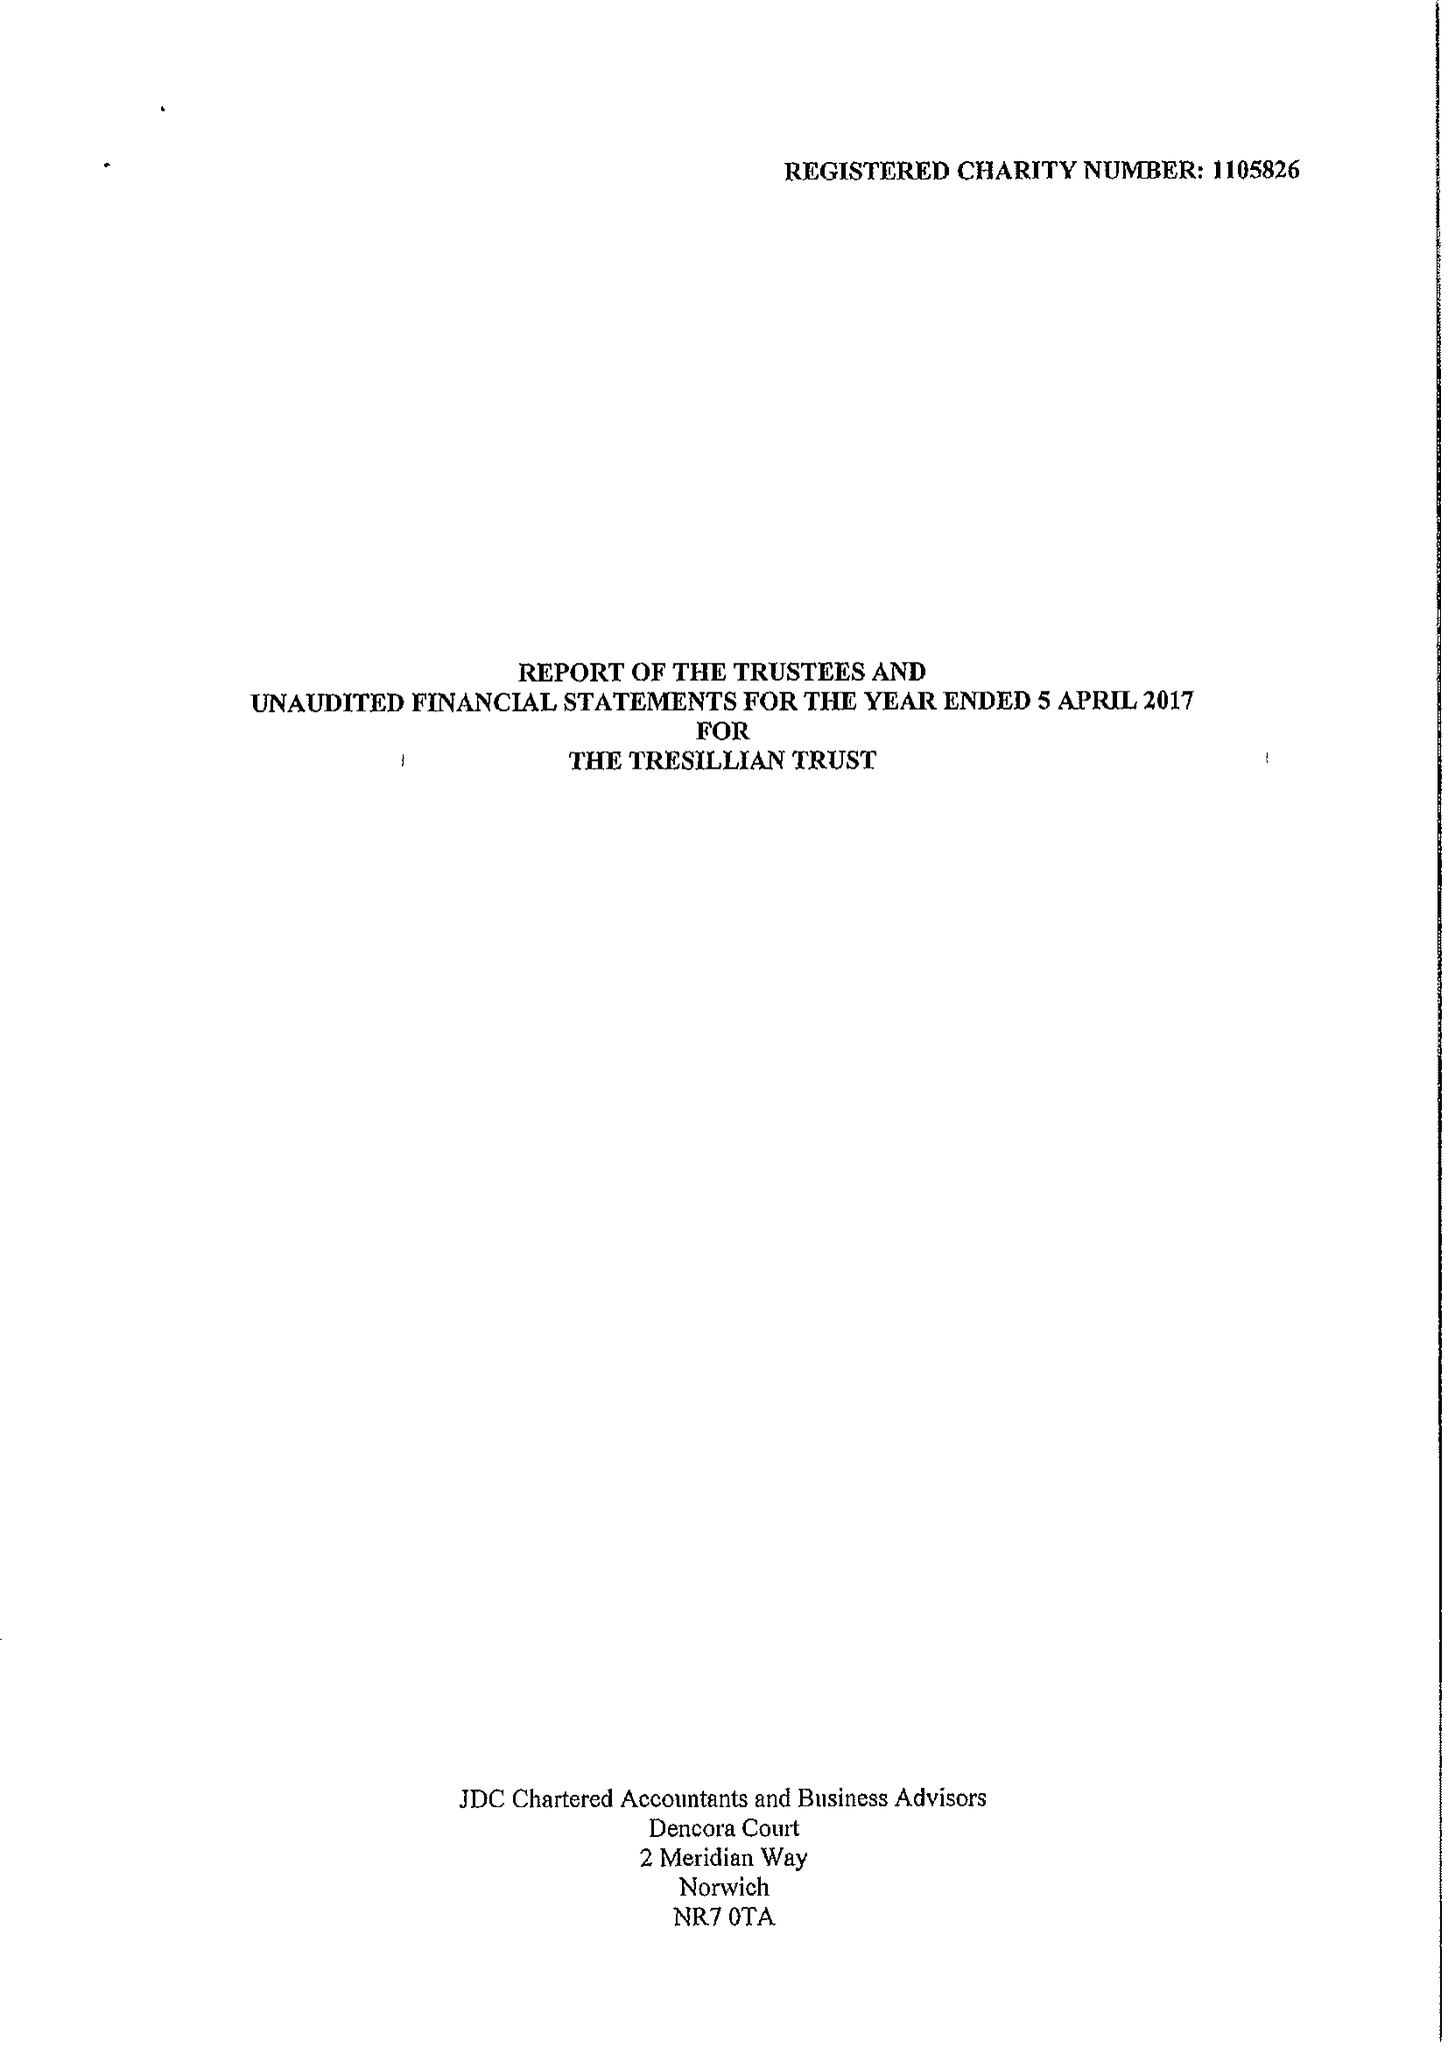What is the value for the address__post_town?
Answer the question using a single word or phrase. LONDON 